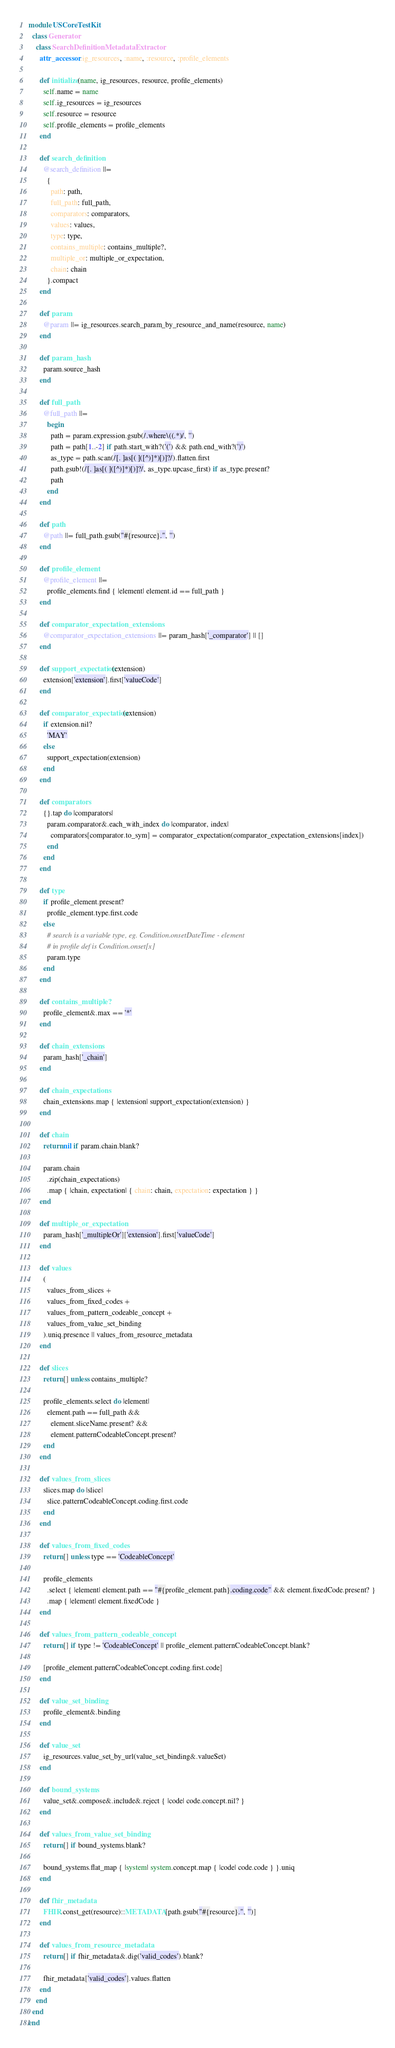<code> <loc_0><loc_0><loc_500><loc_500><_Ruby_>module USCoreTestKit
  class Generator
    class SearchDefinitionMetadataExtractor
      attr_accessor :ig_resources, :name, :resource, :profile_elements

      def initialize(name, ig_resources, resource, profile_elements)
        self.name = name
        self.ig_resources = ig_resources
        self.resource = resource
        self.profile_elements = profile_elements
      end

      def search_definition
        @search_definition ||=
          {
            path: path,
            full_path: full_path,
            comparators: comparators,
            values: values,
            type: type,
            contains_multiple: contains_multiple?,
            multiple_or: multiple_or_expectation,
            chain: chain
          }.compact
      end

      def param
        @param ||= ig_resources.search_param_by_resource_and_name(resource, name)
      end

      def param_hash
        param.source_hash
      end

      def full_path
        @full_path ||=
          begin
            path = param.expression.gsub(/.where\((.*)/, '')
            path = path[1..-2] if path.start_with?('(') && path.end_with?(')')
            as_type = path.scan(/[. ]as[( ]([^)]*)[)]?/).flatten.first
            path.gsub!(/[. ]as[( ]([^)]*)[)]?/, as_type.upcase_first) if as_type.present?
            path
          end
      end

      def path
        @path ||= full_path.gsub("#{resource}.", '')
      end

      def profile_element
        @profile_element ||=
          profile_elements.find { |element| element.id == full_path }
      end

      def comparator_expectation_extensions
        @comparator_expectation_extensions ||= param_hash['_comparator'] || []
      end

      def support_expectation(extension)
        extension['extension'].first['valueCode']
      end

      def comparator_expectation(extension)
        if extension.nil?
          'MAY'
        else
          support_expectation(extension)
        end
      end

      def comparators
        {}.tap do |comparators|
          param.comparator&.each_with_index do |comparator, index|
            comparators[comparator.to_sym] = comparator_expectation(comparator_expectation_extensions[index])
          end
        end
      end

      def type
        if profile_element.present?
          profile_element.type.first.code
        else
          # search is a variable type, eg. Condition.onsetDateTime - element
          # in profile def is Condition.onset[x]
          param.type
        end
      end

      def contains_multiple?
        profile_element&.max == '*'
      end

      def chain_extensions
        param_hash['_chain']
      end

      def chain_expectations
        chain_extensions.map { |extension| support_expectation(extension) }
      end

      def chain
        return nil if param.chain.blank?

        param.chain
          .zip(chain_expectations)
          .map { |chain, expectation| { chain: chain, expectation: expectation } }
      end

      def multiple_or_expectation
        param_hash['_multipleOr']['extension'].first['valueCode']
      end

      def values
        (
          values_from_slices +
          values_from_fixed_codes +
          values_from_pattern_codeable_concept +
          values_from_value_set_binding
        ).uniq.presence || values_from_resource_metadata
      end

      def slices
        return [] unless contains_multiple?

        profile_elements.select do |element|
          element.path == full_path &&
            element.sliceName.present? &&
            element.patternCodeableConcept.present?
        end
      end

      def values_from_slices
        slices.map do |slice|
          slice.patternCodeableConcept.coding.first.code
        end
      end

      def values_from_fixed_codes
        return [] unless type == 'CodeableConcept'

        profile_elements
          .select { |element| element.path == "#{profile_element.path}.coding.code" && element.fixedCode.present? }
          .map { |element| element.fixedCode }
      end

      def values_from_pattern_codeable_concept
        return [] if type != 'CodeableConcept' || profile_element.patternCodeableConcept.blank?

        [profile_element.patternCodeableConcept.coding.first.code]
      end

      def value_set_binding
        profile_element&.binding
      end

      def value_set
        ig_resources.value_set_by_url(value_set_binding&.valueSet)
      end

      def bound_systems
        value_set&.compose&.include&.reject { |code| code.concept.nil? }
      end

      def values_from_value_set_binding
        return [] if bound_systems.blank?

        bound_systems.flat_map { |system| system.concept.map { |code| code.code } }.uniq
      end

      def fhir_metadata
        FHIR.const_get(resource)::METADATA[path.gsub("#{resource}.", '')]
      end

      def values_from_resource_metadata
        return [] if fhir_metadata&.dig('valid_codes').blank?

        fhir_metadata['valid_codes'].values.flatten
      end
    end
  end
end
</code> 